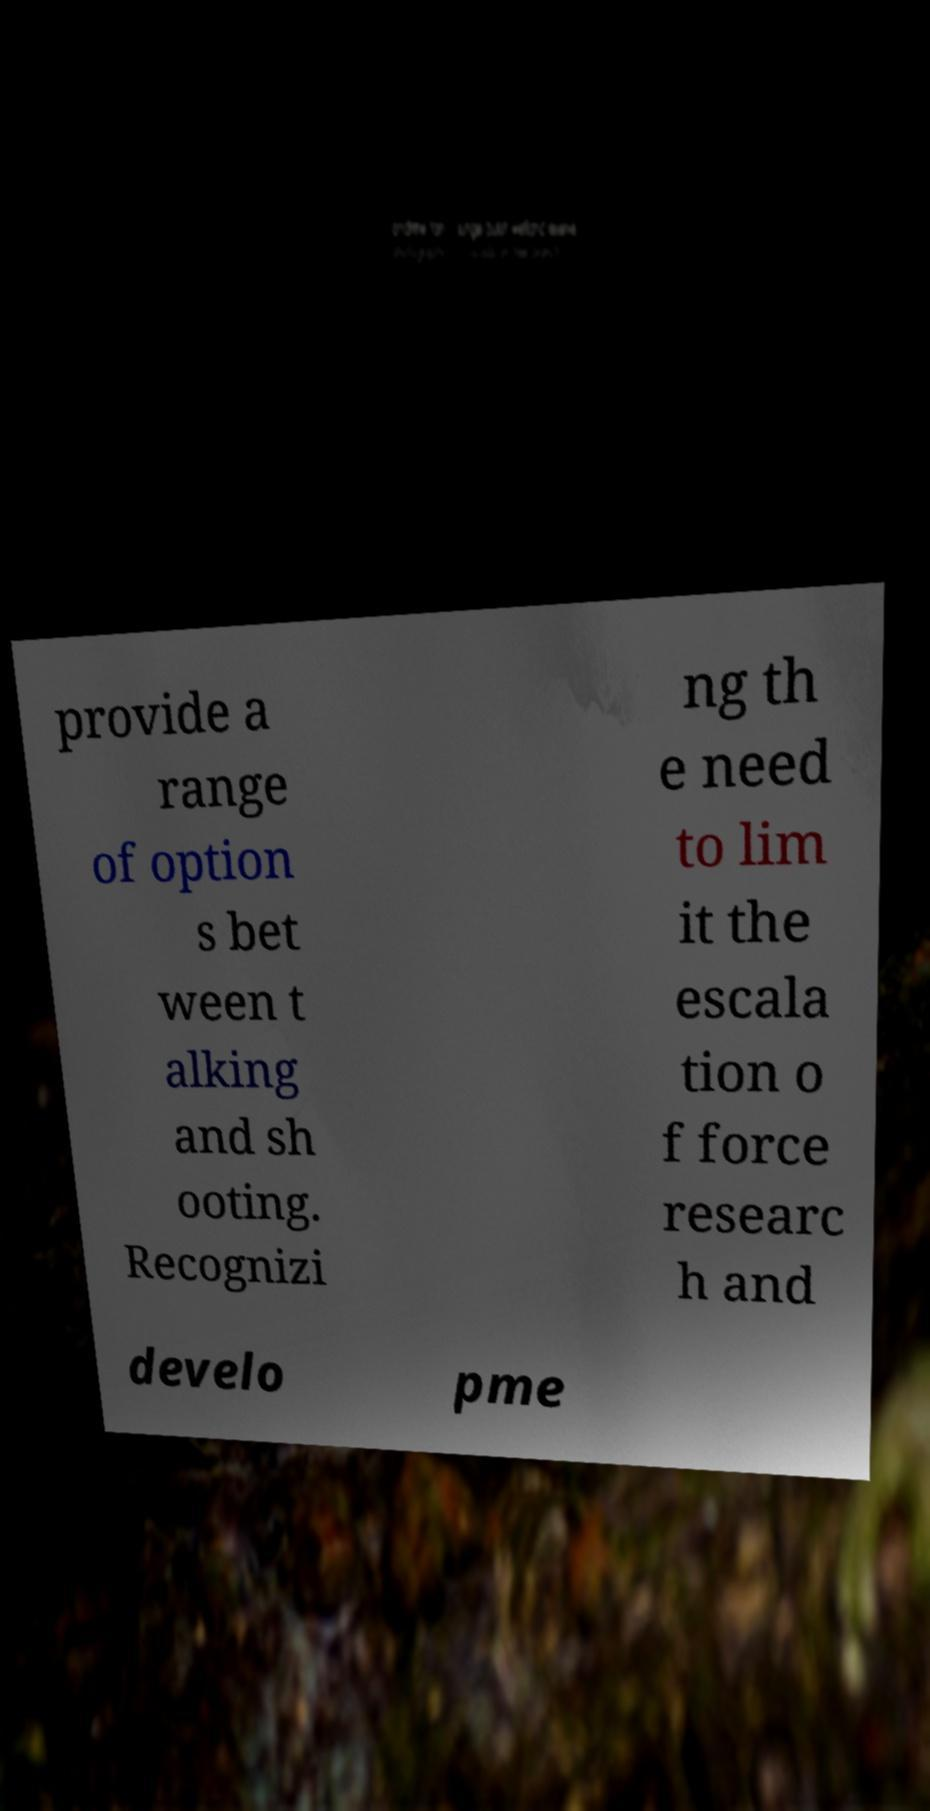Can you read and provide the text displayed in the image?This photo seems to have some interesting text. Can you extract and type it out for me? provide a range of option s bet ween t alking and sh ooting. Recognizi ng th e need to lim it the escala tion o f force researc h and develo pme 